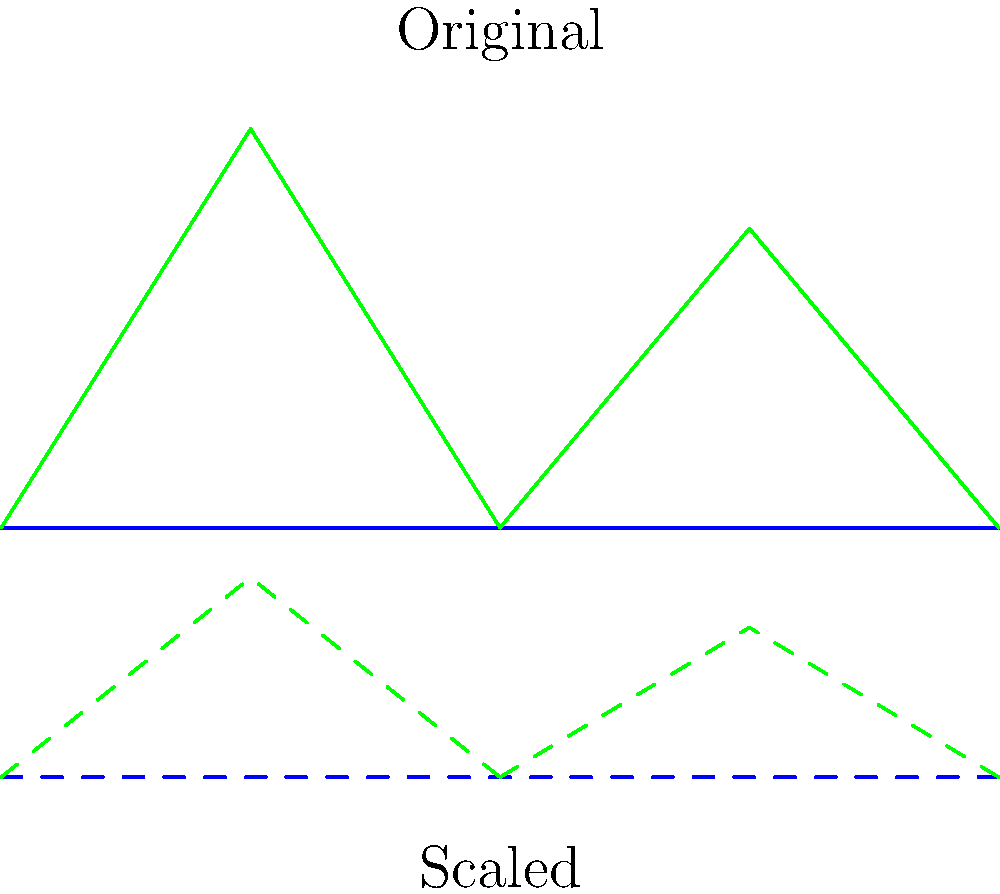In the context of creating perspective in a 2D side-scrolling game background, what transformation has been applied to the lower set of mountains and ground, and how does this contribute to the artistic representation of depth in the game world? To understand the transformation applied and its artistic significance:

1. Observe the two sets of shapes in the image: the original (solid lines) and the transformed (dashed lines).

2. Compare the width of both sets: They remain the same horizontally, indicating no horizontal scaling.

3. Compare the height of both sets: The transformed set is shorter, suggesting a vertical scaling.

4. The vertical scaling factor can be determined by comparing heights: The transformed set is half the height of the original.

5. This transformation is a non-uniform scaling, specifically $scale(1, 0.5)$, where the x-scale is 1 (unchanged) and the y-scale is 0.5 (half).

6. In the context of a side-scrolling game, this scaling creates a sense of depth:
   a. The scaled version represents elements further in the background.
   b. Objects appear smaller (vertically) as they recede into the distance.
   c. This mimics natural perspective, where distant objects appear smaller.

7. Artistically, this technique:
   a. Creates a layered, multi-plane effect, adding depth to the 2D environment.
   b. Allows for parallax scrolling, where background elements move slower than foreground elements.
   c. Enhances the immersive quality of the game world, bridging 2D aesthetics with 3D spatial perception.

8. This transformation showcases how mathematical concepts (scaling transformations) can be leveraged to create artistic effects in video games, supporting the argument that games can be a form of artistic expression.
Answer: Non-uniform scaling (scale(1, 0.5)) to create depth perception 